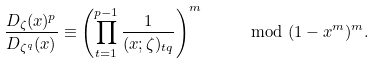Convert formula to latex. <formula><loc_0><loc_0><loc_500><loc_500>\frac { D _ { \zeta } ( x ) ^ { p } } { D _ { \zeta ^ { q } } ( x ) } \equiv \left ( \prod _ { t = 1 } ^ { p - 1 } \frac { 1 } { ( x ; \zeta ) _ { t q } } \right ) ^ { m } \quad \mod ( 1 - x ^ { m } ) ^ { m } .</formula> 